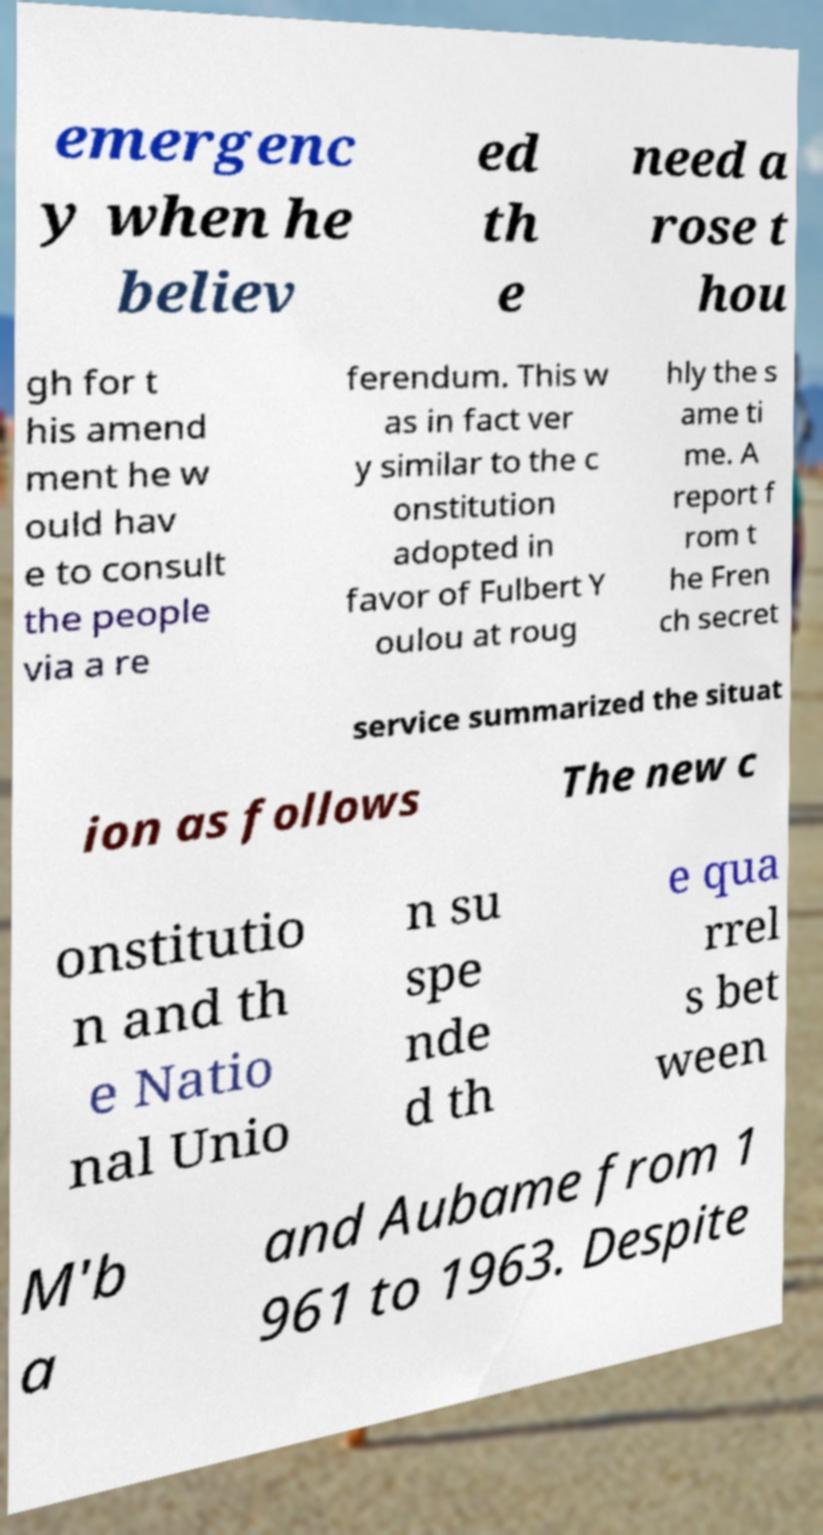I need the written content from this picture converted into text. Can you do that? emergenc y when he believ ed th e need a rose t hou gh for t his amend ment he w ould hav e to consult the people via a re ferendum. This w as in fact ver y similar to the c onstitution adopted in favor of Fulbert Y oulou at roug hly the s ame ti me. A report f rom t he Fren ch secret service summarized the situat ion as follows The new c onstitutio n and th e Natio nal Unio n su spe nde d th e qua rrel s bet ween M'b a and Aubame from 1 961 to 1963. Despite 